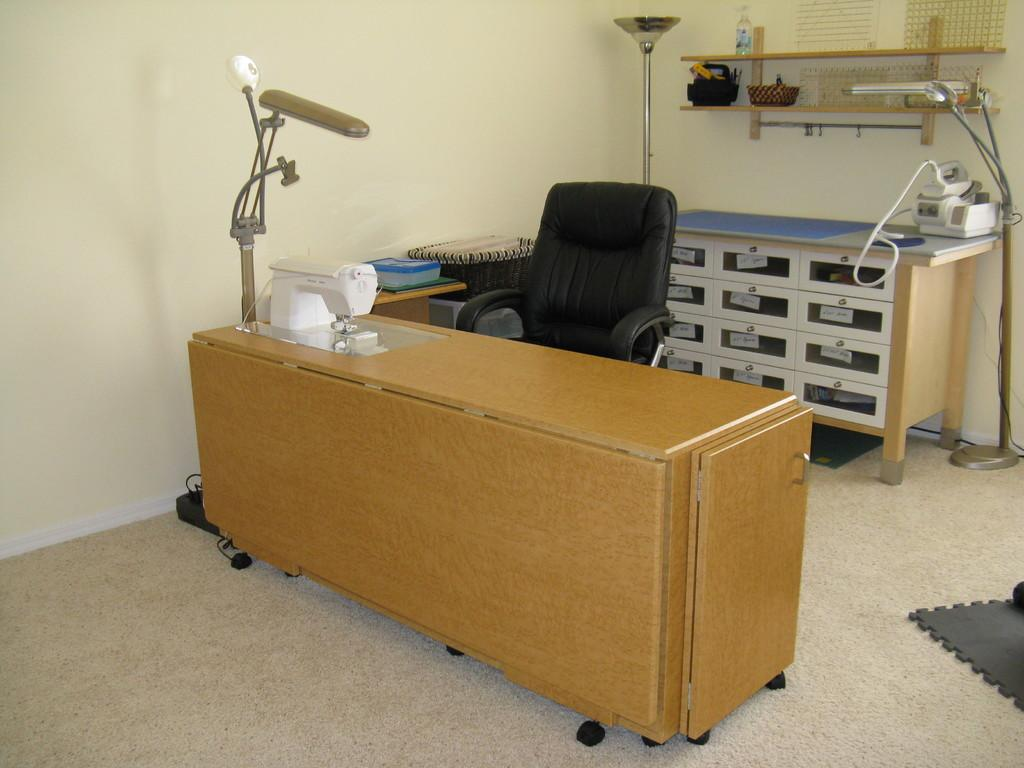What type of furniture is present in the image? There is a chair and a desk in the image. What other objects can be seen in the image? There is a machine, lamps, and a cupboard in the image. What type of window is visible in the image? There is no window present in the image. What event is taking place in the image? The image does not depict an event; it shows a room with various objects and furniture. 